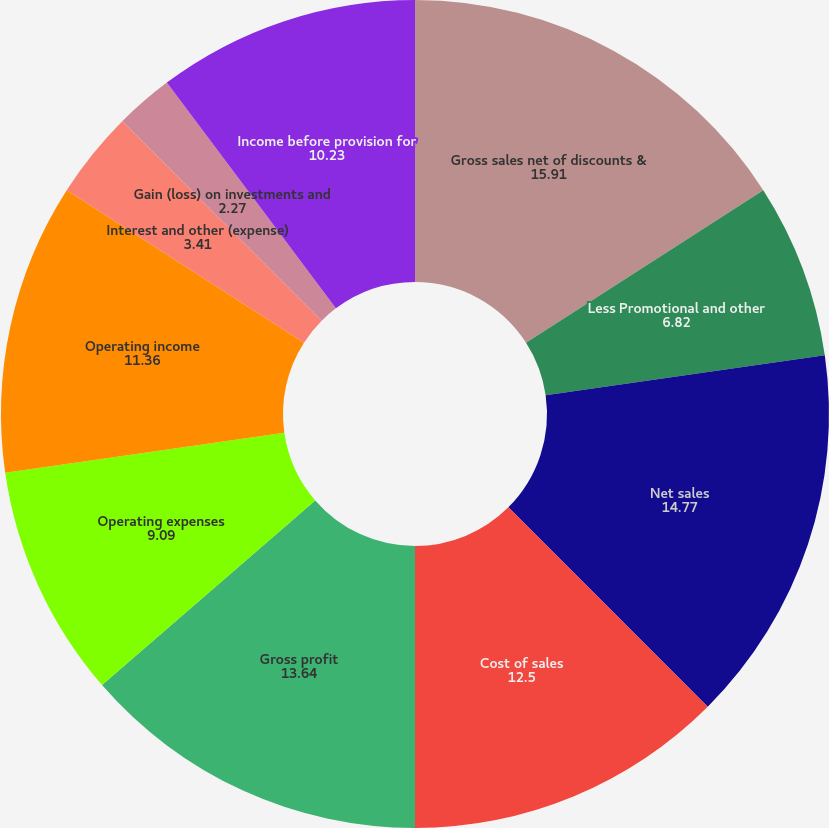Convert chart. <chart><loc_0><loc_0><loc_500><loc_500><pie_chart><fcel>Gross sales net of discounts &<fcel>Less Promotional and other<fcel>Net sales<fcel>Cost of sales<fcel>Gross profit<fcel>Operating expenses<fcel>Operating income<fcel>Interest and other (expense)<fcel>Gain (loss) on investments and<fcel>Income before provision for<nl><fcel>15.91%<fcel>6.82%<fcel>14.77%<fcel>12.5%<fcel>13.64%<fcel>9.09%<fcel>11.36%<fcel>3.41%<fcel>2.27%<fcel>10.23%<nl></chart> 